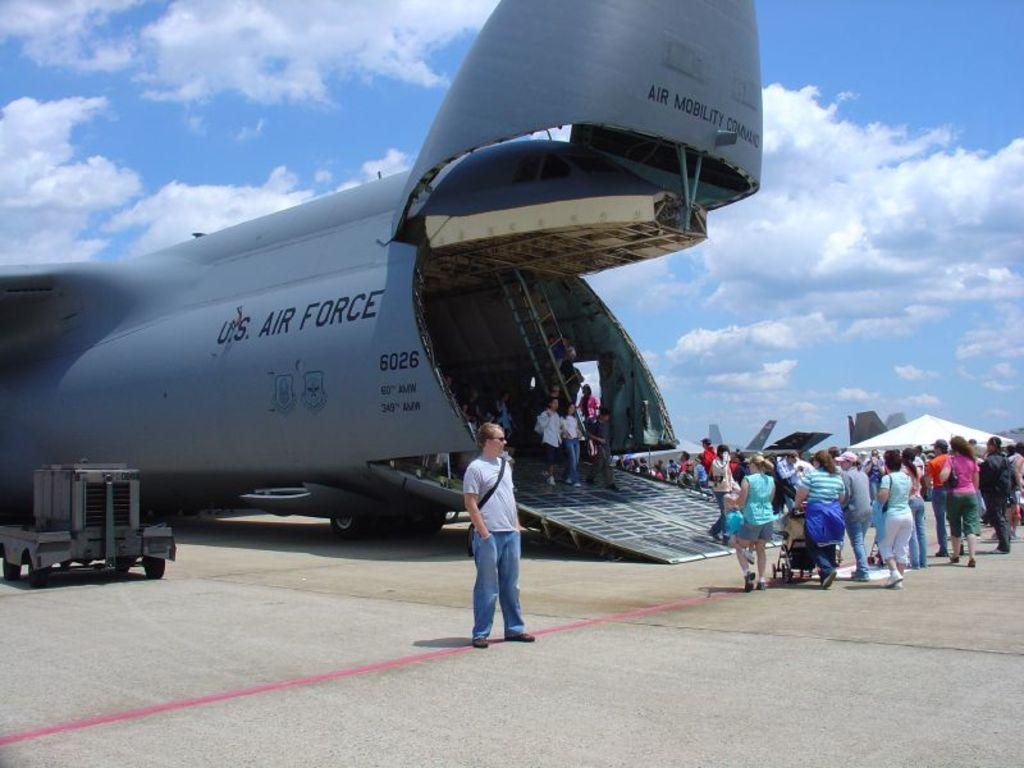<image>
Write a terse but informative summary of the picture. People are lined up to see an Air Force plane. 